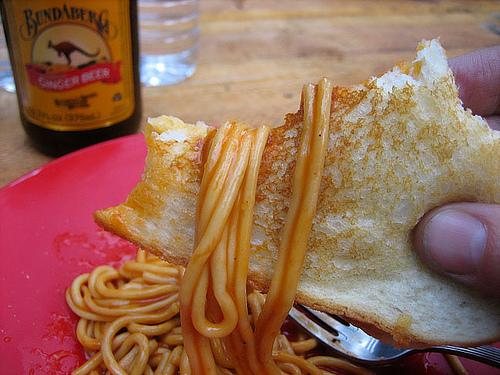Is there pasta in the image?
Concise answer only. Yes. Does the person want to take another bite?
Quick response, please. Yes. Is there any meat in this meal?
Answer briefly. No. 